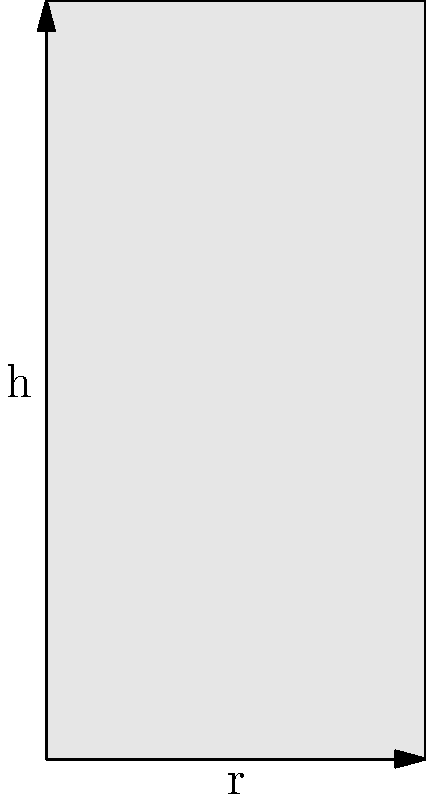As a boutique owner looking to sell handmade skincare products, you need to design cylindrical jars for storing beauty creams. Given that the volume of the jar must be 150 cm³, what should be the radius and height of the jar to minimize the amount of material used for its surface area? Assume the jar has a circular base and top. To solve this problem, we'll follow these steps:

1. Express the volume of the cylinder in terms of radius (r) and height (h):
   $V = \pi r^2 h = 150$ cm³

2. Express the surface area of the cylinder:
   $S = 2\pi r^2 + 2\pi r h$

3. Use the volume equation to express h in terms of r:
   $h = \frac{150}{\pi r^2}$

4. Substitute this expression for h into the surface area equation:
   $S = 2\pi r^2 + 2\pi r (\frac{150}{\pi r^2}) = 2\pi r^2 + \frac{300}{r}$

5. To find the minimum surface area, differentiate S with respect to r and set it to zero:
   $\frac{dS}{dr} = 4\pi r - \frac{300}{r^2} = 0$

6. Solve this equation:
   $4\pi r^3 = 300$
   $r^3 = \frac{300}{4\pi} = 23.873$
   $r = \sqrt[3]{23.873} = 2.88$ cm

7. Calculate h using the volume equation:
   $h = \frac{150}{\pi (2.88)^2} = 5.76$ cm

8. The optimal dimensions are:
   Radius (r) = 2.88 cm
   Height (h) = 5.76 cm

These dimensions will minimize the surface area of the cylindrical jar while maintaining the required volume of 150 cm³.
Answer: r = 2.88 cm, h = 5.76 cm 